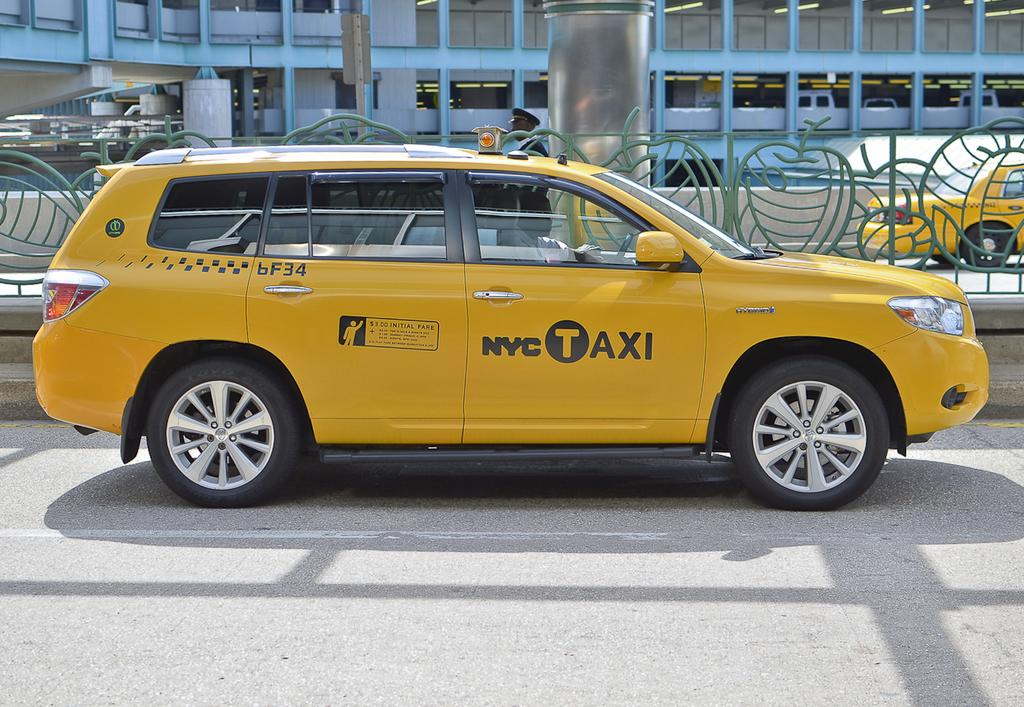<image>
Create a compact narrative representing the image presented. A yellow vehicle with NYC Taxi on the side. 